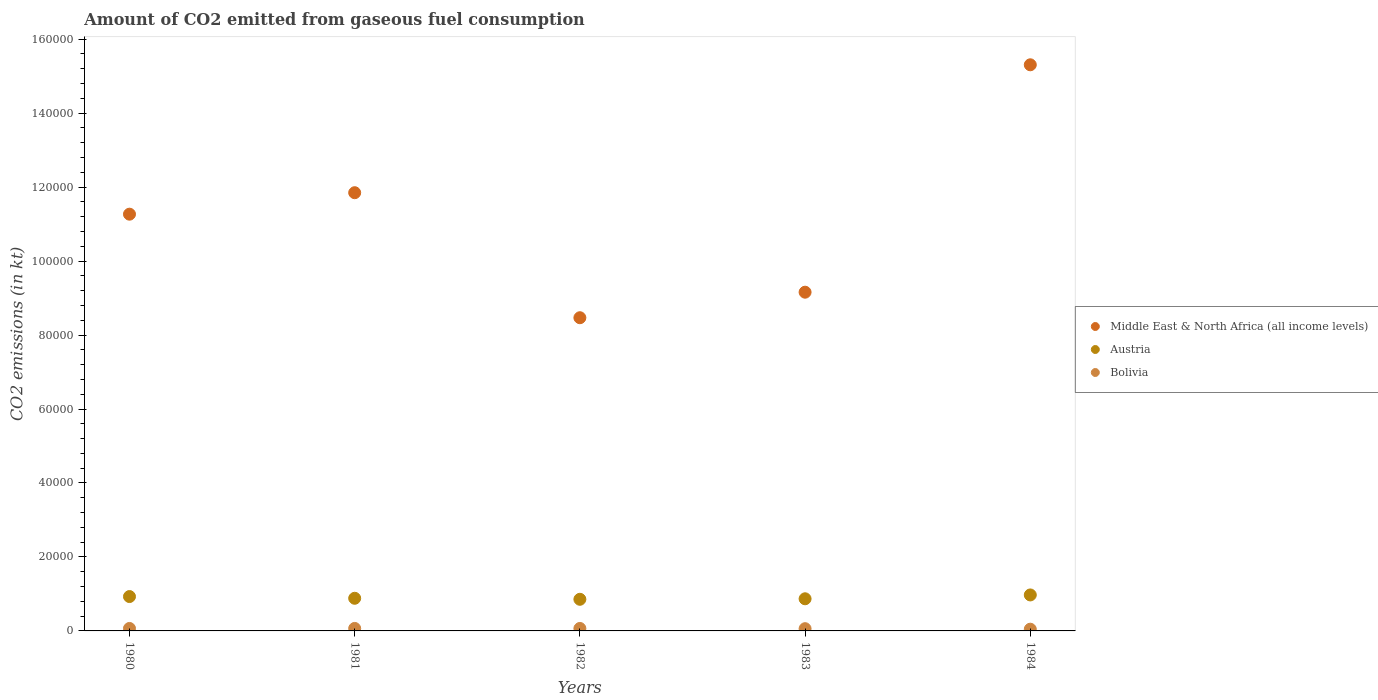How many different coloured dotlines are there?
Provide a short and direct response. 3. Is the number of dotlines equal to the number of legend labels?
Offer a very short reply. Yes. What is the amount of CO2 emitted in Austria in 1984?
Ensure brevity in your answer.  9728.55. Across all years, what is the maximum amount of CO2 emitted in Bolivia?
Offer a terse response. 674.73. Across all years, what is the minimum amount of CO2 emitted in Middle East & North Africa (all income levels)?
Provide a short and direct response. 8.47e+04. In which year was the amount of CO2 emitted in Middle East & North Africa (all income levels) maximum?
Offer a terse response. 1984. In which year was the amount of CO2 emitted in Austria minimum?
Your response must be concise. 1982. What is the total amount of CO2 emitted in Middle East & North Africa (all income levels) in the graph?
Your answer should be compact. 5.61e+05. What is the difference between the amount of CO2 emitted in Middle East & North Africa (all income levels) in 1983 and the amount of CO2 emitted in Austria in 1980?
Your answer should be compact. 8.23e+04. What is the average amount of CO2 emitted in Austria per year?
Keep it short and to the point. 9017.89. In the year 1981, what is the difference between the amount of CO2 emitted in Austria and amount of CO2 emitted in Middle East & North Africa (all income levels)?
Provide a short and direct response. -1.10e+05. In how many years, is the amount of CO2 emitted in Bolivia greater than 88000 kt?
Your answer should be compact. 0. What is the ratio of the amount of CO2 emitted in Bolivia in 1980 to that in 1983?
Provide a short and direct response. 1.1. Is the difference between the amount of CO2 emitted in Austria in 1981 and 1984 greater than the difference between the amount of CO2 emitted in Middle East & North Africa (all income levels) in 1981 and 1984?
Offer a terse response. Yes. What is the difference between the highest and the second highest amount of CO2 emitted in Middle East & North Africa (all income levels)?
Offer a terse response. 3.46e+04. What is the difference between the highest and the lowest amount of CO2 emitted in Middle East & North Africa (all income levels)?
Make the answer very short. 6.84e+04. In how many years, is the amount of CO2 emitted in Bolivia greater than the average amount of CO2 emitted in Bolivia taken over all years?
Give a very brief answer. 3. Is the sum of the amount of CO2 emitted in Austria in 1981 and 1984 greater than the maximum amount of CO2 emitted in Bolivia across all years?
Your answer should be very brief. Yes. How many dotlines are there?
Offer a very short reply. 3. What is the difference between two consecutive major ticks on the Y-axis?
Give a very brief answer. 2.00e+04. Are the values on the major ticks of Y-axis written in scientific E-notation?
Offer a terse response. No. Does the graph contain any zero values?
Give a very brief answer. No. What is the title of the graph?
Provide a short and direct response. Amount of CO2 emitted from gaseous fuel consumption. Does "Netherlands" appear as one of the legend labels in the graph?
Give a very brief answer. No. What is the label or title of the X-axis?
Your answer should be compact. Years. What is the label or title of the Y-axis?
Provide a short and direct response. CO2 emissions (in kt). What is the CO2 emissions (in kt) of Middle East & North Africa (all income levels) in 1980?
Provide a short and direct response. 1.13e+05. What is the CO2 emissions (in kt) of Austria in 1980?
Ensure brevity in your answer.  9292.18. What is the CO2 emissions (in kt) in Bolivia in 1980?
Give a very brief answer. 667.39. What is the CO2 emissions (in kt) of Middle East & North Africa (all income levels) in 1981?
Give a very brief answer. 1.18e+05. What is the CO2 emissions (in kt) of Austria in 1981?
Your answer should be very brief. 8826.47. What is the CO2 emissions (in kt) of Bolivia in 1981?
Your answer should be very brief. 674.73. What is the CO2 emissions (in kt) in Middle East & North Africa (all income levels) in 1982?
Your answer should be compact. 8.47e+04. What is the CO2 emissions (in kt) of Austria in 1982?
Keep it short and to the point. 8551.44. What is the CO2 emissions (in kt) in Bolivia in 1982?
Ensure brevity in your answer.  667.39. What is the CO2 emissions (in kt) in Middle East & North Africa (all income levels) in 1983?
Ensure brevity in your answer.  9.16e+04. What is the CO2 emissions (in kt) of Austria in 1983?
Your answer should be compact. 8690.79. What is the CO2 emissions (in kt) in Bolivia in 1983?
Your answer should be very brief. 605.05. What is the CO2 emissions (in kt) in Middle East & North Africa (all income levels) in 1984?
Provide a short and direct response. 1.53e+05. What is the CO2 emissions (in kt) in Austria in 1984?
Keep it short and to the point. 9728.55. What is the CO2 emissions (in kt) of Bolivia in 1984?
Make the answer very short. 465.71. Across all years, what is the maximum CO2 emissions (in kt) of Middle East & North Africa (all income levels)?
Your response must be concise. 1.53e+05. Across all years, what is the maximum CO2 emissions (in kt) of Austria?
Your response must be concise. 9728.55. Across all years, what is the maximum CO2 emissions (in kt) of Bolivia?
Keep it short and to the point. 674.73. Across all years, what is the minimum CO2 emissions (in kt) of Middle East & North Africa (all income levels)?
Provide a succinct answer. 8.47e+04. Across all years, what is the minimum CO2 emissions (in kt) in Austria?
Your answer should be very brief. 8551.44. Across all years, what is the minimum CO2 emissions (in kt) in Bolivia?
Your response must be concise. 465.71. What is the total CO2 emissions (in kt) of Middle East & North Africa (all income levels) in the graph?
Give a very brief answer. 5.61e+05. What is the total CO2 emissions (in kt) of Austria in the graph?
Give a very brief answer. 4.51e+04. What is the total CO2 emissions (in kt) in Bolivia in the graph?
Ensure brevity in your answer.  3080.28. What is the difference between the CO2 emissions (in kt) of Middle East & North Africa (all income levels) in 1980 and that in 1981?
Give a very brief answer. -5805.66. What is the difference between the CO2 emissions (in kt) of Austria in 1980 and that in 1981?
Make the answer very short. 465.71. What is the difference between the CO2 emissions (in kt) of Bolivia in 1980 and that in 1981?
Offer a terse response. -7.33. What is the difference between the CO2 emissions (in kt) of Middle East & North Africa (all income levels) in 1980 and that in 1982?
Ensure brevity in your answer.  2.80e+04. What is the difference between the CO2 emissions (in kt) in Austria in 1980 and that in 1982?
Provide a short and direct response. 740.73. What is the difference between the CO2 emissions (in kt) of Middle East & North Africa (all income levels) in 1980 and that in 1983?
Keep it short and to the point. 2.11e+04. What is the difference between the CO2 emissions (in kt) of Austria in 1980 and that in 1983?
Make the answer very short. 601.39. What is the difference between the CO2 emissions (in kt) of Bolivia in 1980 and that in 1983?
Your response must be concise. 62.34. What is the difference between the CO2 emissions (in kt) of Middle East & North Africa (all income levels) in 1980 and that in 1984?
Provide a short and direct response. -4.04e+04. What is the difference between the CO2 emissions (in kt) in Austria in 1980 and that in 1984?
Keep it short and to the point. -436.37. What is the difference between the CO2 emissions (in kt) in Bolivia in 1980 and that in 1984?
Keep it short and to the point. 201.69. What is the difference between the CO2 emissions (in kt) in Middle East & North Africa (all income levels) in 1981 and that in 1982?
Your answer should be very brief. 3.38e+04. What is the difference between the CO2 emissions (in kt) of Austria in 1981 and that in 1982?
Your answer should be very brief. 275.02. What is the difference between the CO2 emissions (in kt) in Bolivia in 1981 and that in 1982?
Give a very brief answer. 7.33. What is the difference between the CO2 emissions (in kt) of Middle East & North Africa (all income levels) in 1981 and that in 1983?
Offer a very short reply. 2.69e+04. What is the difference between the CO2 emissions (in kt) of Austria in 1981 and that in 1983?
Ensure brevity in your answer.  135.68. What is the difference between the CO2 emissions (in kt) in Bolivia in 1981 and that in 1983?
Your answer should be compact. 69.67. What is the difference between the CO2 emissions (in kt) of Middle East & North Africa (all income levels) in 1981 and that in 1984?
Give a very brief answer. -3.46e+04. What is the difference between the CO2 emissions (in kt) in Austria in 1981 and that in 1984?
Keep it short and to the point. -902.08. What is the difference between the CO2 emissions (in kt) of Bolivia in 1981 and that in 1984?
Give a very brief answer. 209.02. What is the difference between the CO2 emissions (in kt) of Middle East & North Africa (all income levels) in 1982 and that in 1983?
Make the answer very short. -6901.35. What is the difference between the CO2 emissions (in kt) in Austria in 1982 and that in 1983?
Your response must be concise. -139.35. What is the difference between the CO2 emissions (in kt) of Bolivia in 1982 and that in 1983?
Ensure brevity in your answer.  62.34. What is the difference between the CO2 emissions (in kt) in Middle East & North Africa (all income levels) in 1982 and that in 1984?
Provide a succinct answer. -6.84e+04. What is the difference between the CO2 emissions (in kt) in Austria in 1982 and that in 1984?
Keep it short and to the point. -1177.11. What is the difference between the CO2 emissions (in kt) of Bolivia in 1982 and that in 1984?
Give a very brief answer. 201.69. What is the difference between the CO2 emissions (in kt) in Middle East & North Africa (all income levels) in 1983 and that in 1984?
Ensure brevity in your answer.  -6.15e+04. What is the difference between the CO2 emissions (in kt) in Austria in 1983 and that in 1984?
Ensure brevity in your answer.  -1037.76. What is the difference between the CO2 emissions (in kt) of Bolivia in 1983 and that in 1984?
Provide a short and direct response. 139.35. What is the difference between the CO2 emissions (in kt) in Middle East & North Africa (all income levels) in 1980 and the CO2 emissions (in kt) in Austria in 1981?
Your answer should be compact. 1.04e+05. What is the difference between the CO2 emissions (in kt) in Middle East & North Africa (all income levels) in 1980 and the CO2 emissions (in kt) in Bolivia in 1981?
Make the answer very short. 1.12e+05. What is the difference between the CO2 emissions (in kt) of Austria in 1980 and the CO2 emissions (in kt) of Bolivia in 1981?
Offer a very short reply. 8617.45. What is the difference between the CO2 emissions (in kt) of Middle East & North Africa (all income levels) in 1980 and the CO2 emissions (in kt) of Austria in 1982?
Offer a terse response. 1.04e+05. What is the difference between the CO2 emissions (in kt) in Middle East & North Africa (all income levels) in 1980 and the CO2 emissions (in kt) in Bolivia in 1982?
Ensure brevity in your answer.  1.12e+05. What is the difference between the CO2 emissions (in kt) of Austria in 1980 and the CO2 emissions (in kt) of Bolivia in 1982?
Ensure brevity in your answer.  8624.78. What is the difference between the CO2 emissions (in kt) of Middle East & North Africa (all income levels) in 1980 and the CO2 emissions (in kt) of Austria in 1983?
Ensure brevity in your answer.  1.04e+05. What is the difference between the CO2 emissions (in kt) of Middle East & North Africa (all income levels) in 1980 and the CO2 emissions (in kt) of Bolivia in 1983?
Your answer should be compact. 1.12e+05. What is the difference between the CO2 emissions (in kt) in Austria in 1980 and the CO2 emissions (in kt) in Bolivia in 1983?
Provide a short and direct response. 8687.12. What is the difference between the CO2 emissions (in kt) of Middle East & North Africa (all income levels) in 1980 and the CO2 emissions (in kt) of Austria in 1984?
Your answer should be very brief. 1.03e+05. What is the difference between the CO2 emissions (in kt) of Middle East & North Africa (all income levels) in 1980 and the CO2 emissions (in kt) of Bolivia in 1984?
Provide a succinct answer. 1.12e+05. What is the difference between the CO2 emissions (in kt) of Austria in 1980 and the CO2 emissions (in kt) of Bolivia in 1984?
Your response must be concise. 8826.47. What is the difference between the CO2 emissions (in kt) of Middle East & North Africa (all income levels) in 1981 and the CO2 emissions (in kt) of Austria in 1982?
Ensure brevity in your answer.  1.10e+05. What is the difference between the CO2 emissions (in kt) of Middle East & North Africa (all income levels) in 1981 and the CO2 emissions (in kt) of Bolivia in 1982?
Ensure brevity in your answer.  1.18e+05. What is the difference between the CO2 emissions (in kt) in Austria in 1981 and the CO2 emissions (in kt) in Bolivia in 1982?
Keep it short and to the point. 8159.07. What is the difference between the CO2 emissions (in kt) in Middle East & North Africa (all income levels) in 1981 and the CO2 emissions (in kt) in Austria in 1983?
Your response must be concise. 1.10e+05. What is the difference between the CO2 emissions (in kt) in Middle East & North Africa (all income levels) in 1981 and the CO2 emissions (in kt) in Bolivia in 1983?
Make the answer very short. 1.18e+05. What is the difference between the CO2 emissions (in kt) of Austria in 1981 and the CO2 emissions (in kt) of Bolivia in 1983?
Provide a short and direct response. 8221.41. What is the difference between the CO2 emissions (in kt) in Middle East & North Africa (all income levels) in 1981 and the CO2 emissions (in kt) in Austria in 1984?
Your answer should be very brief. 1.09e+05. What is the difference between the CO2 emissions (in kt) in Middle East & North Africa (all income levels) in 1981 and the CO2 emissions (in kt) in Bolivia in 1984?
Your response must be concise. 1.18e+05. What is the difference between the CO2 emissions (in kt) of Austria in 1981 and the CO2 emissions (in kt) of Bolivia in 1984?
Make the answer very short. 8360.76. What is the difference between the CO2 emissions (in kt) of Middle East & North Africa (all income levels) in 1982 and the CO2 emissions (in kt) of Austria in 1983?
Your answer should be very brief. 7.60e+04. What is the difference between the CO2 emissions (in kt) in Middle East & North Africa (all income levels) in 1982 and the CO2 emissions (in kt) in Bolivia in 1983?
Give a very brief answer. 8.41e+04. What is the difference between the CO2 emissions (in kt) in Austria in 1982 and the CO2 emissions (in kt) in Bolivia in 1983?
Your answer should be compact. 7946.39. What is the difference between the CO2 emissions (in kt) in Middle East & North Africa (all income levels) in 1982 and the CO2 emissions (in kt) in Austria in 1984?
Make the answer very short. 7.50e+04. What is the difference between the CO2 emissions (in kt) in Middle East & North Africa (all income levels) in 1982 and the CO2 emissions (in kt) in Bolivia in 1984?
Provide a succinct answer. 8.42e+04. What is the difference between the CO2 emissions (in kt) in Austria in 1982 and the CO2 emissions (in kt) in Bolivia in 1984?
Keep it short and to the point. 8085.73. What is the difference between the CO2 emissions (in kt) of Middle East & North Africa (all income levels) in 1983 and the CO2 emissions (in kt) of Austria in 1984?
Give a very brief answer. 8.19e+04. What is the difference between the CO2 emissions (in kt) of Middle East & North Africa (all income levels) in 1983 and the CO2 emissions (in kt) of Bolivia in 1984?
Provide a succinct answer. 9.11e+04. What is the difference between the CO2 emissions (in kt) of Austria in 1983 and the CO2 emissions (in kt) of Bolivia in 1984?
Make the answer very short. 8225.08. What is the average CO2 emissions (in kt) of Middle East & North Africa (all income levels) per year?
Give a very brief answer. 1.12e+05. What is the average CO2 emissions (in kt) of Austria per year?
Provide a succinct answer. 9017.89. What is the average CO2 emissions (in kt) in Bolivia per year?
Provide a succinct answer. 616.06. In the year 1980, what is the difference between the CO2 emissions (in kt) in Middle East & North Africa (all income levels) and CO2 emissions (in kt) in Austria?
Keep it short and to the point. 1.03e+05. In the year 1980, what is the difference between the CO2 emissions (in kt) of Middle East & North Africa (all income levels) and CO2 emissions (in kt) of Bolivia?
Offer a terse response. 1.12e+05. In the year 1980, what is the difference between the CO2 emissions (in kt) in Austria and CO2 emissions (in kt) in Bolivia?
Your answer should be very brief. 8624.78. In the year 1981, what is the difference between the CO2 emissions (in kt) in Middle East & North Africa (all income levels) and CO2 emissions (in kt) in Austria?
Make the answer very short. 1.10e+05. In the year 1981, what is the difference between the CO2 emissions (in kt) of Middle East & North Africa (all income levels) and CO2 emissions (in kt) of Bolivia?
Give a very brief answer. 1.18e+05. In the year 1981, what is the difference between the CO2 emissions (in kt) of Austria and CO2 emissions (in kt) of Bolivia?
Offer a terse response. 8151.74. In the year 1982, what is the difference between the CO2 emissions (in kt) of Middle East & North Africa (all income levels) and CO2 emissions (in kt) of Austria?
Make the answer very short. 7.61e+04. In the year 1982, what is the difference between the CO2 emissions (in kt) in Middle East & North Africa (all income levels) and CO2 emissions (in kt) in Bolivia?
Offer a very short reply. 8.40e+04. In the year 1982, what is the difference between the CO2 emissions (in kt) in Austria and CO2 emissions (in kt) in Bolivia?
Make the answer very short. 7884.05. In the year 1983, what is the difference between the CO2 emissions (in kt) of Middle East & North Africa (all income levels) and CO2 emissions (in kt) of Austria?
Provide a short and direct response. 8.29e+04. In the year 1983, what is the difference between the CO2 emissions (in kt) of Middle East & North Africa (all income levels) and CO2 emissions (in kt) of Bolivia?
Give a very brief answer. 9.10e+04. In the year 1983, what is the difference between the CO2 emissions (in kt) of Austria and CO2 emissions (in kt) of Bolivia?
Your answer should be compact. 8085.73. In the year 1984, what is the difference between the CO2 emissions (in kt) in Middle East & North Africa (all income levels) and CO2 emissions (in kt) in Austria?
Your answer should be compact. 1.43e+05. In the year 1984, what is the difference between the CO2 emissions (in kt) in Middle East & North Africa (all income levels) and CO2 emissions (in kt) in Bolivia?
Make the answer very short. 1.53e+05. In the year 1984, what is the difference between the CO2 emissions (in kt) of Austria and CO2 emissions (in kt) of Bolivia?
Your answer should be compact. 9262.84. What is the ratio of the CO2 emissions (in kt) in Middle East & North Africa (all income levels) in 1980 to that in 1981?
Your answer should be compact. 0.95. What is the ratio of the CO2 emissions (in kt) in Austria in 1980 to that in 1981?
Your response must be concise. 1.05. What is the ratio of the CO2 emissions (in kt) of Bolivia in 1980 to that in 1981?
Offer a terse response. 0.99. What is the ratio of the CO2 emissions (in kt) of Middle East & North Africa (all income levels) in 1980 to that in 1982?
Your answer should be compact. 1.33. What is the ratio of the CO2 emissions (in kt) in Austria in 1980 to that in 1982?
Make the answer very short. 1.09. What is the ratio of the CO2 emissions (in kt) of Bolivia in 1980 to that in 1982?
Your response must be concise. 1. What is the ratio of the CO2 emissions (in kt) in Middle East & North Africa (all income levels) in 1980 to that in 1983?
Give a very brief answer. 1.23. What is the ratio of the CO2 emissions (in kt) in Austria in 1980 to that in 1983?
Provide a short and direct response. 1.07. What is the ratio of the CO2 emissions (in kt) of Bolivia in 1980 to that in 1983?
Provide a short and direct response. 1.1. What is the ratio of the CO2 emissions (in kt) in Middle East & North Africa (all income levels) in 1980 to that in 1984?
Ensure brevity in your answer.  0.74. What is the ratio of the CO2 emissions (in kt) of Austria in 1980 to that in 1984?
Keep it short and to the point. 0.96. What is the ratio of the CO2 emissions (in kt) of Bolivia in 1980 to that in 1984?
Provide a succinct answer. 1.43. What is the ratio of the CO2 emissions (in kt) in Middle East & North Africa (all income levels) in 1981 to that in 1982?
Your answer should be compact. 1.4. What is the ratio of the CO2 emissions (in kt) of Austria in 1981 to that in 1982?
Your answer should be very brief. 1.03. What is the ratio of the CO2 emissions (in kt) in Bolivia in 1981 to that in 1982?
Provide a succinct answer. 1.01. What is the ratio of the CO2 emissions (in kt) in Middle East & North Africa (all income levels) in 1981 to that in 1983?
Your answer should be very brief. 1.29. What is the ratio of the CO2 emissions (in kt) in Austria in 1981 to that in 1983?
Provide a short and direct response. 1.02. What is the ratio of the CO2 emissions (in kt) of Bolivia in 1981 to that in 1983?
Your answer should be very brief. 1.12. What is the ratio of the CO2 emissions (in kt) of Middle East & North Africa (all income levels) in 1981 to that in 1984?
Provide a short and direct response. 0.77. What is the ratio of the CO2 emissions (in kt) in Austria in 1981 to that in 1984?
Your answer should be very brief. 0.91. What is the ratio of the CO2 emissions (in kt) of Bolivia in 1981 to that in 1984?
Make the answer very short. 1.45. What is the ratio of the CO2 emissions (in kt) in Middle East & North Africa (all income levels) in 1982 to that in 1983?
Give a very brief answer. 0.92. What is the ratio of the CO2 emissions (in kt) of Austria in 1982 to that in 1983?
Provide a short and direct response. 0.98. What is the ratio of the CO2 emissions (in kt) in Bolivia in 1982 to that in 1983?
Keep it short and to the point. 1.1. What is the ratio of the CO2 emissions (in kt) in Middle East & North Africa (all income levels) in 1982 to that in 1984?
Provide a short and direct response. 0.55. What is the ratio of the CO2 emissions (in kt) of Austria in 1982 to that in 1984?
Offer a very short reply. 0.88. What is the ratio of the CO2 emissions (in kt) in Bolivia in 1982 to that in 1984?
Your response must be concise. 1.43. What is the ratio of the CO2 emissions (in kt) in Middle East & North Africa (all income levels) in 1983 to that in 1984?
Make the answer very short. 0.6. What is the ratio of the CO2 emissions (in kt) of Austria in 1983 to that in 1984?
Your answer should be compact. 0.89. What is the ratio of the CO2 emissions (in kt) in Bolivia in 1983 to that in 1984?
Ensure brevity in your answer.  1.3. What is the difference between the highest and the second highest CO2 emissions (in kt) in Middle East & North Africa (all income levels)?
Your answer should be compact. 3.46e+04. What is the difference between the highest and the second highest CO2 emissions (in kt) in Austria?
Your answer should be compact. 436.37. What is the difference between the highest and the second highest CO2 emissions (in kt) of Bolivia?
Your response must be concise. 7.33. What is the difference between the highest and the lowest CO2 emissions (in kt) in Middle East & North Africa (all income levels)?
Your response must be concise. 6.84e+04. What is the difference between the highest and the lowest CO2 emissions (in kt) of Austria?
Your response must be concise. 1177.11. What is the difference between the highest and the lowest CO2 emissions (in kt) in Bolivia?
Give a very brief answer. 209.02. 